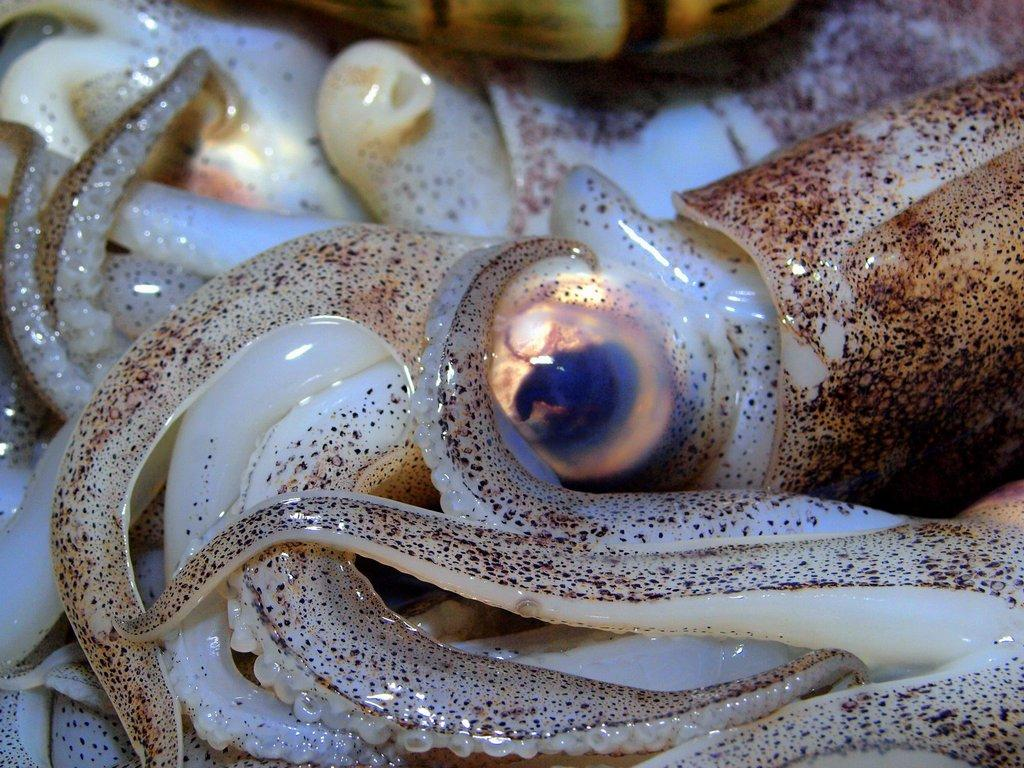What type of animal can be seen in the image? There is an aquatic animal in the image. How many spots are visible on the pizzas in the image? There are no pizzas present in the image; it features an aquatic animal. What direction is the animal facing in the image? The fact provided does not specify the direction the animal is facing, so it cannot be determined from the image. 